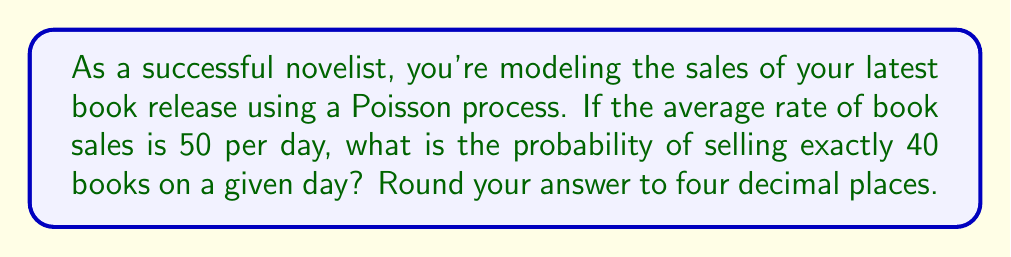Provide a solution to this math problem. Let's approach this step-by-step:

1) The Poisson distribution is used to model the number of events occurring in a fixed interval of time when these events occur with a known average rate.

2) The probability mass function of a Poisson distribution is given by:

   $$P(X = k) = \frac{e^{-\lambda} \lambda^k}{k!}$$

   where:
   - $\lambda$ is the average rate of events
   - $k$ is the number of events we're interested in
   - $e$ is Euler's number (approximately 2.71828)

3) In this case:
   - $\lambda = 50$ (average rate of 50 books sold per day)
   - $k = 40$ (we're interested in the probability of selling exactly 40 books)

4) Let's substitute these values into the formula:

   $$P(X = 40) = \frac{e^{-50} 50^{40}}{40!}$$

5) Now, let's calculate this step-by-step:
   
   a) First, calculate $e^{-50}$:
      $e^{-50} \approx 1.9287 \times 10^{-22}$
   
   b) Next, calculate $50^{40}$:
      $50^{40} \approx 9.0949 \times 10^{67}$
   
   c) Calculate 40!:
      $40! \approx 8.1592 \times 10^{47}$

   d) Now, put it all together:
      
      $$\frac{(1.9287 \times 10^{-22})(9.0949 \times 10^{67})}{8.1592 \times 10^{47}} \approx 0.0214$$

6) Rounding to four decimal places, we get 0.0214.
Answer: 0.0214 